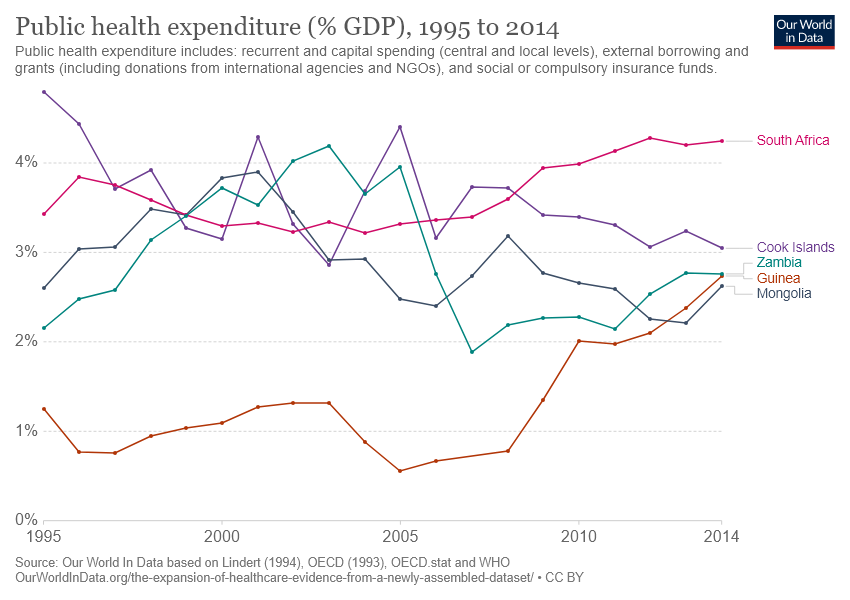Specify some key components in this picture. The countries of South Africa, Cook Islands, and Zambia have all reached public health expenditure levels higher than 4% in at least one year. Guinea had the lowest public expenditure in 2005 among all the countries. 